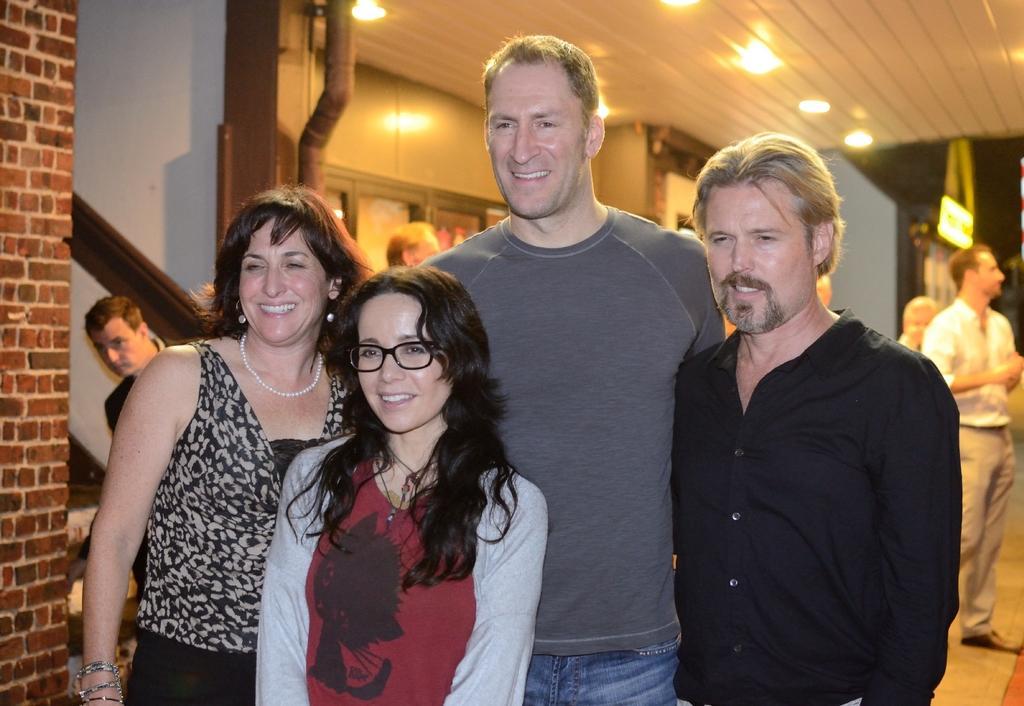Please provide a concise description of this image. In this image, we can see a few people standing. We can see the wall. We can also see the roof with some lights. We can see a pole, some windows and the ground. 